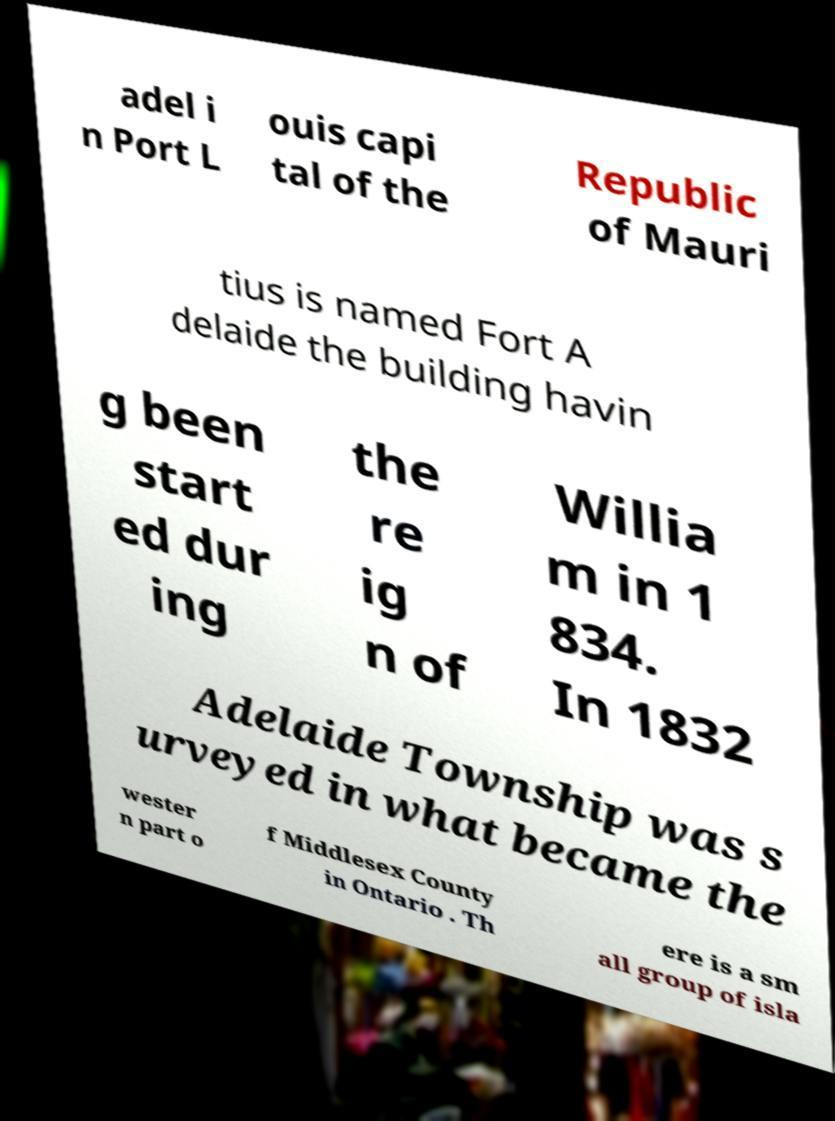What messages or text are displayed in this image? I need them in a readable, typed format. adel i n Port L ouis capi tal of the Republic of Mauri tius is named Fort A delaide the building havin g been start ed dur ing the re ig n of Willia m in 1 834. In 1832 Adelaide Township was s urveyed in what became the wester n part o f Middlesex County in Ontario . Th ere is a sm all group of isla 